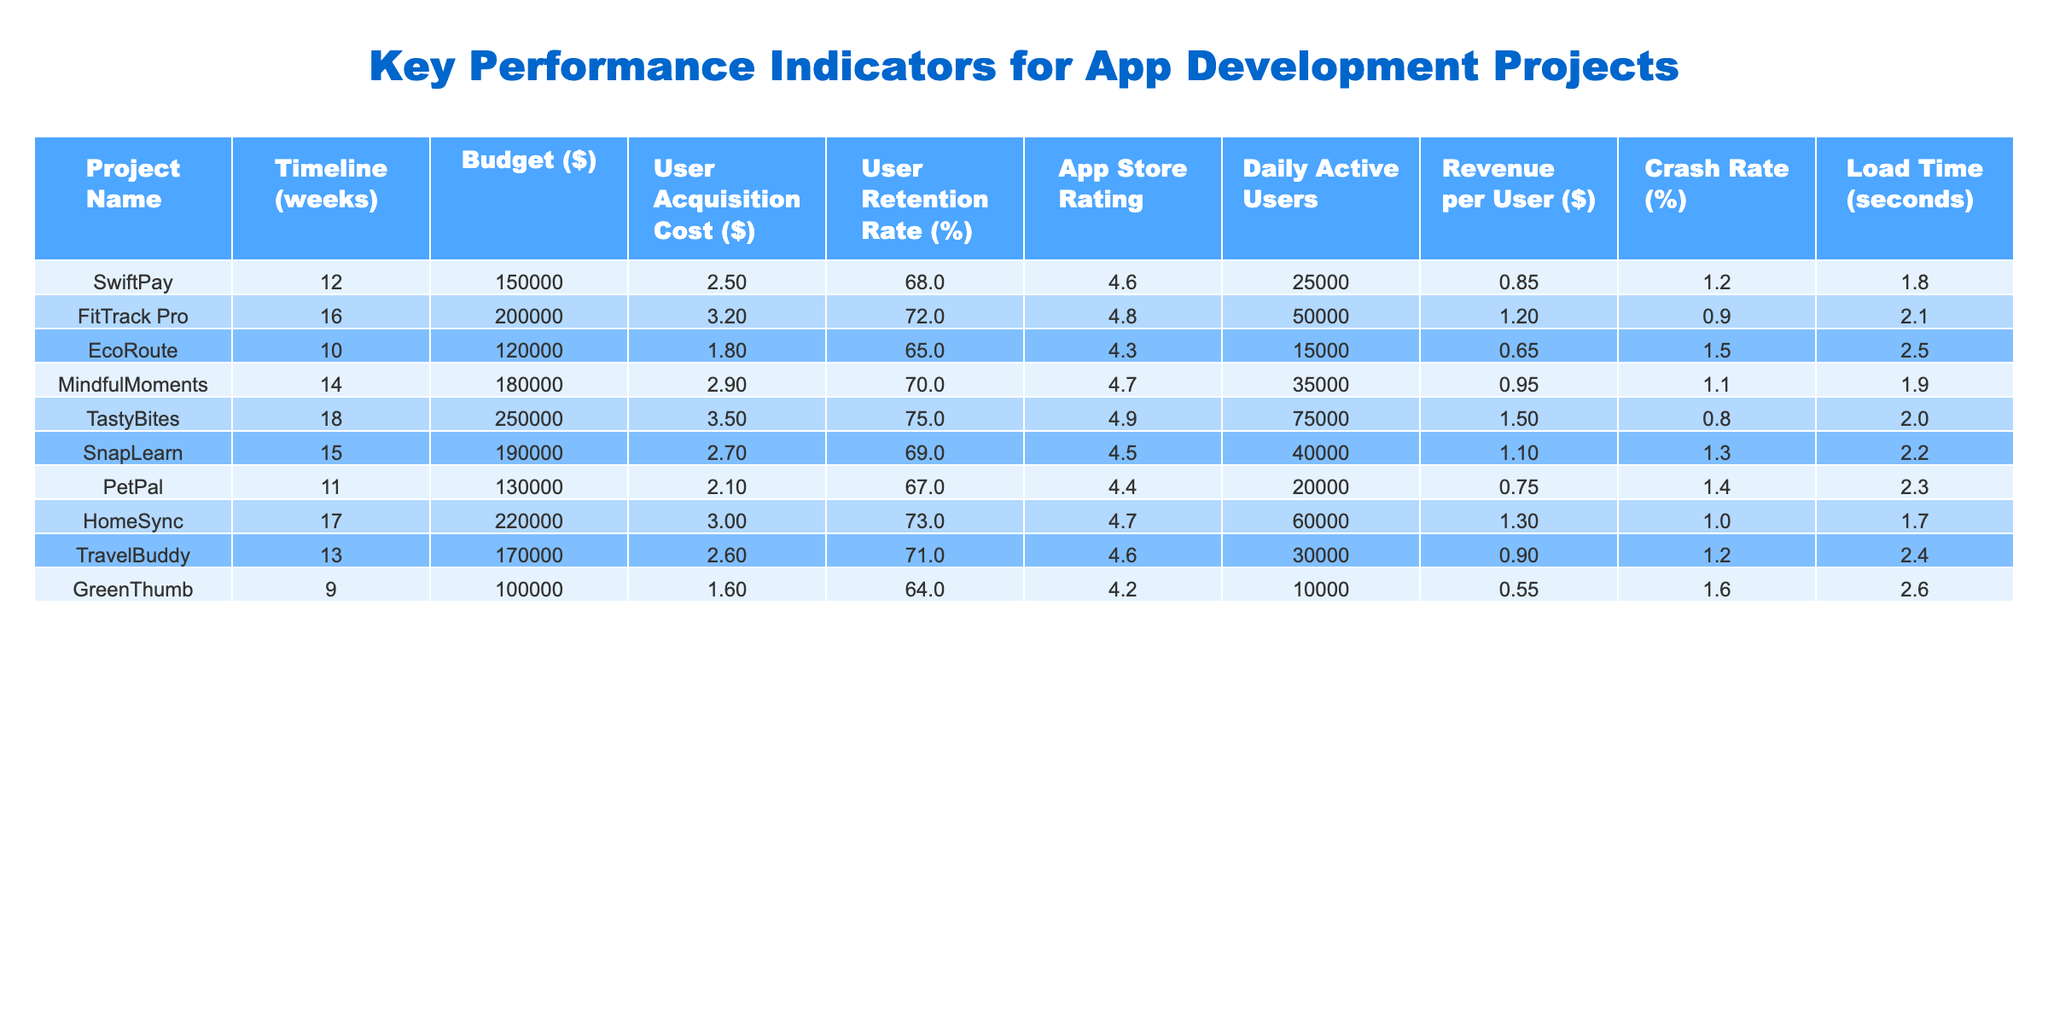What is the app store rating for TastyBites? The app store rating for TastyBites is provided directly in the table under the respective column.
Answer: 4.9 What is the user retention rate for EcoRoute? The user retention rate for EcoRoute can be found by locating the row associated with EcoRoute in the table and checking the value in the User Retention Rate column.
Answer: 65% Which project has the highest revenue per user? By comparing the Revenue per User column values, TastyBites has the highest value at $1.5, while other projects have lower values.
Answer: TastyBites What is the average user acquisition cost across all projects? To find the average, sum all user acquisition costs and divide by the number of projects: (2.5 + 3.2 + 1.8 + 2.9 + 3.5 + 2.7 + 2.1 + 3.0 + 2.6 + 1.6) = 24.9, and there are 10 projects, so the average is 24.9 / 10 = 2.49.
Answer: 2.49 Which project has the lowest crash rate? The crash rates can be compared across the table, and EcoRoute has the lowest crash rate at 1.5%.
Answer: EcoRoute Is the daily active user count for FitTrack Pro greater than that for SwiftPay? By checking the respective rows, FitTrack Pro has 50,000 daily active users and SwiftPay has 25,000, confirming FitTrack Pro has more.
Answer: Yes What is the total budget for all projects combined? The budgets are summed up: 150000 + 200000 + 120000 + 180000 + 250000 + 190000 + 130000 + 220000 + 170000 + 100000 = 1,810,000.
Answer: 1,810,000 Do any projects have a daily active user count of fewer than 15,000? By reviewing the Daily Active Users column, GreenThumb has a count of 10,000, which is indeed fewer than 15,000.
Answer: Yes What is the difference in load time between the fastest and slowest projects? EcoRoute has the highest load time at 2.6 seconds and SwiftPay has the lowest at 1.8 seconds; the difference is 2.6 - 1.8 = 0.8 seconds.
Answer: 0.8 seconds Are there more projects with a user retention rate above 70% than below? By checking, FitTrack Pro, TastyBites, and HomeSync have user retention rates above 70%, while the other projects do not; thus, there are three above and four below, indicating more projects below 70%.
Answer: No 